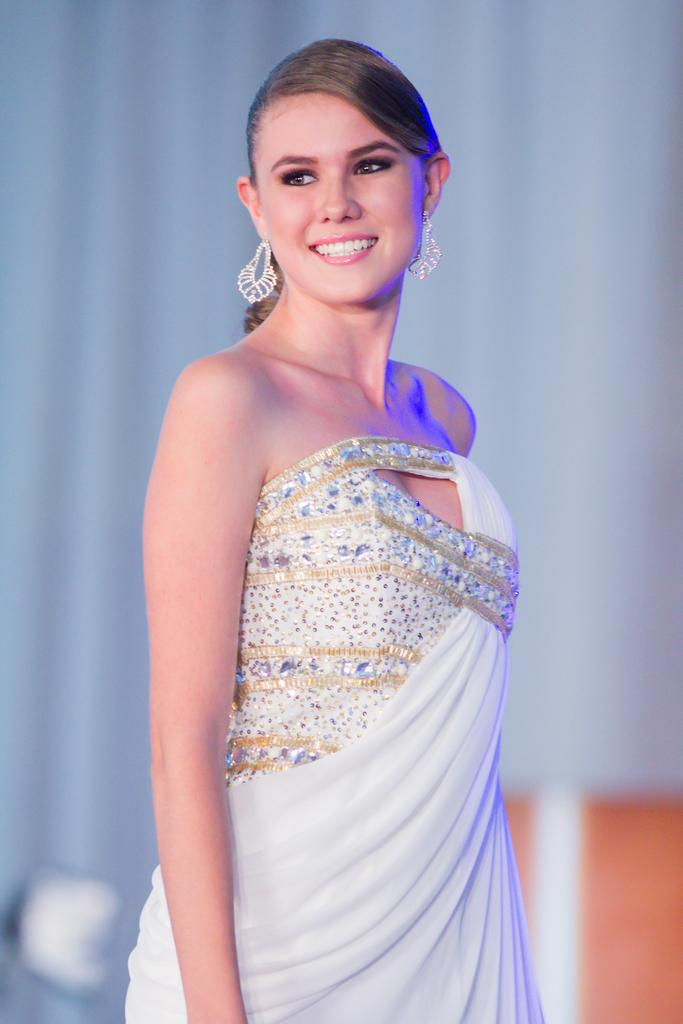Who is present in the image? There is a woman in the image. What is the woman wearing? The woman is wearing a white dress. What is the woman's facial expression in the image? The woman is smiling. What is visible in the background of the image? There is a white curtain visible in the background of the image. What type of ball can be seen in the image? There is no ball present in the image. 